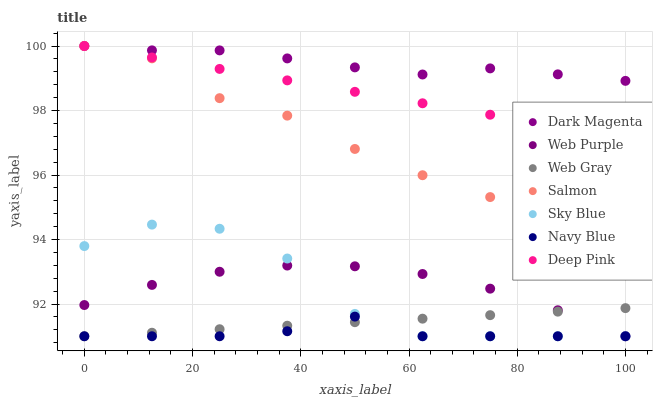Does Navy Blue have the minimum area under the curve?
Answer yes or no. Yes. Does Dark Magenta have the maximum area under the curve?
Answer yes or no. Yes. Does Dark Magenta have the minimum area under the curve?
Answer yes or no. No. Does Navy Blue have the maximum area under the curve?
Answer yes or no. No. Is Deep Pink the smoothest?
Answer yes or no. Yes. Is Sky Blue the roughest?
Answer yes or no. Yes. Is Dark Magenta the smoothest?
Answer yes or no. No. Is Dark Magenta the roughest?
Answer yes or no. No. Does Web Gray have the lowest value?
Answer yes or no. Yes. Does Dark Magenta have the lowest value?
Answer yes or no. No. Does Deep Pink have the highest value?
Answer yes or no. Yes. Does Navy Blue have the highest value?
Answer yes or no. No. Is Sky Blue less than Dark Magenta?
Answer yes or no. Yes. Is Deep Pink greater than Navy Blue?
Answer yes or no. Yes. Does Navy Blue intersect Web Purple?
Answer yes or no. Yes. Is Navy Blue less than Web Purple?
Answer yes or no. No. Is Navy Blue greater than Web Purple?
Answer yes or no. No. Does Sky Blue intersect Dark Magenta?
Answer yes or no. No. 